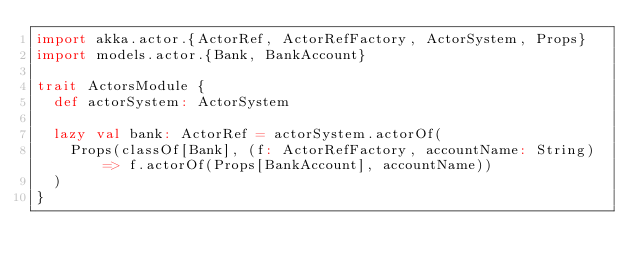Convert code to text. <code><loc_0><loc_0><loc_500><loc_500><_Scala_>import akka.actor.{ActorRef, ActorRefFactory, ActorSystem, Props}
import models.actor.{Bank, BankAccount}

trait ActorsModule {
  def actorSystem: ActorSystem

  lazy val bank: ActorRef = actorSystem.actorOf(
    Props(classOf[Bank], (f: ActorRefFactory, accountName: String) => f.actorOf(Props[BankAccount], accountName))
  )
}
</code> 